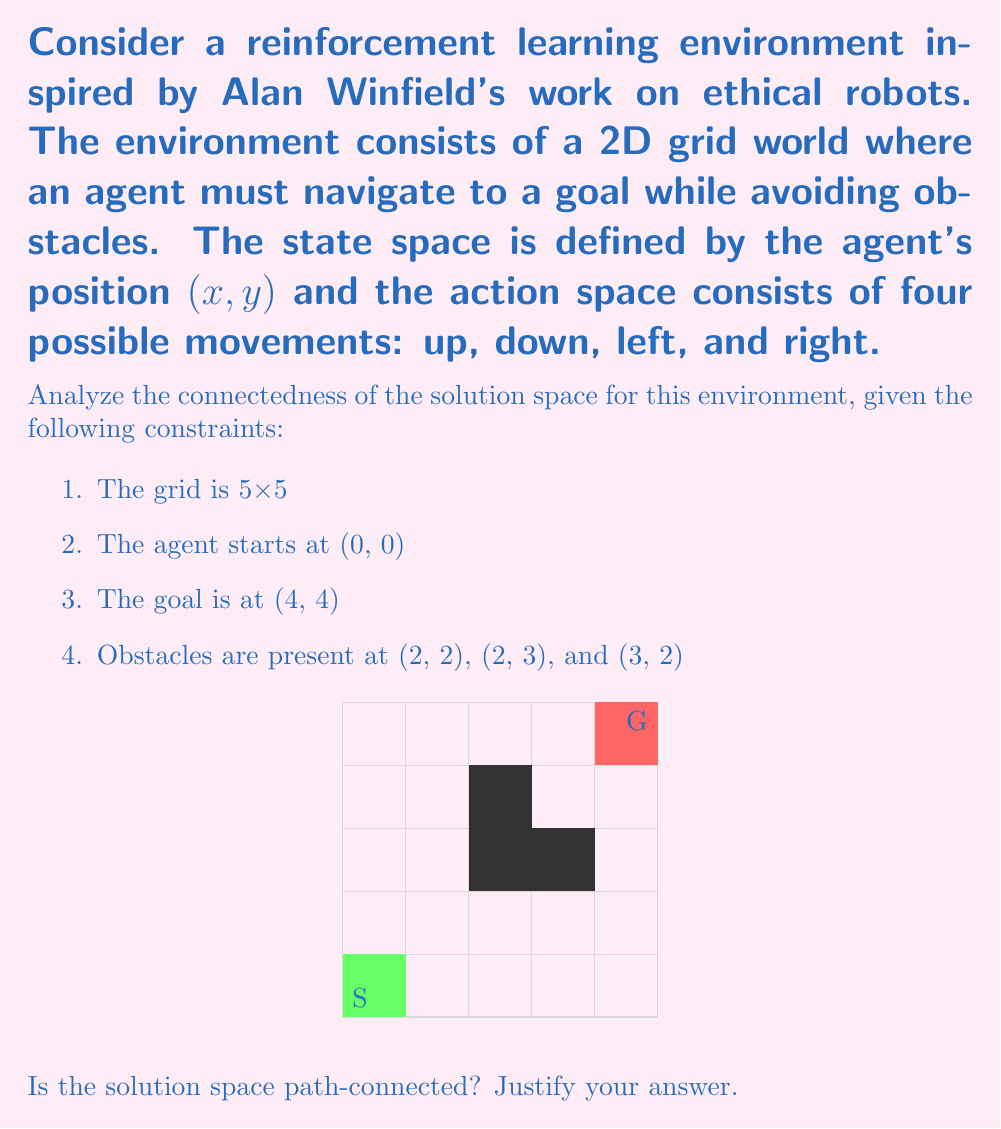Provide a solution to this math problem. To determine if the solution space is path-connected, we need to analyze whether there exists a continuous path between any two solutions in the space. Let's approach this step-by-step:

1. First, let's define what constitutes a solution in this environment:
   A solution is any valid path from the start (0, 0) to the goal (4, 4) that avoids obstacles.

2. Now, let's consider the possible paths:
   - All valid paths must start at (0, 0) and end at (4, 4).
   - Paths cannot go through the obstacles at (2, 2), (2, 3), and (3, 2).

3. We can observe that there are multiple valid paths. For example:
   Path 1: (0,0) → (1,0) → (1,1) → (1,2) → (1,3) → (1,4) → (2,4) → (3,4) → (4,4)
   Path 2: (0,0) → (0,1) → (0,2) → (0,3) → (0,4) → (1,4) → (2,4) → (3,4) → (4,4)

4. To prove path-connectedness, we need to show that we can continuously deform any solution into any other solution.

5. Consider two arbitrary solutions $A$ and $B$. We can create a continuous deformation between them as follows:
   - Start with path $A$.
   - Identify the first point where $A$ and $B$ diverge.
   - Gradually move this divergence point further along the path.
   - Repeat until the entire path matches $B$.

6. This deformation is always possible because:
   - The grid structure ensures that all moves are discrete.
   - The obstacle configuration does not create any isolated "islands" of valid positions.
   - There is always a way to move around obstacles to reach any valid position.

7. The continuity of this deformation in the solution space is maintained because:
   - Each intermediate path during the deformation is also a valid solution.
   - The deformation can be done in arbitrarily small steps.

8. This process can be applied to any pair of solutions, proving that the solution space is indeed path-connected.

Therefore, we can conclude that the solution space for this reinforcement learning environment is path-connected.
Answer: Yes, the solution space is path-connected. 